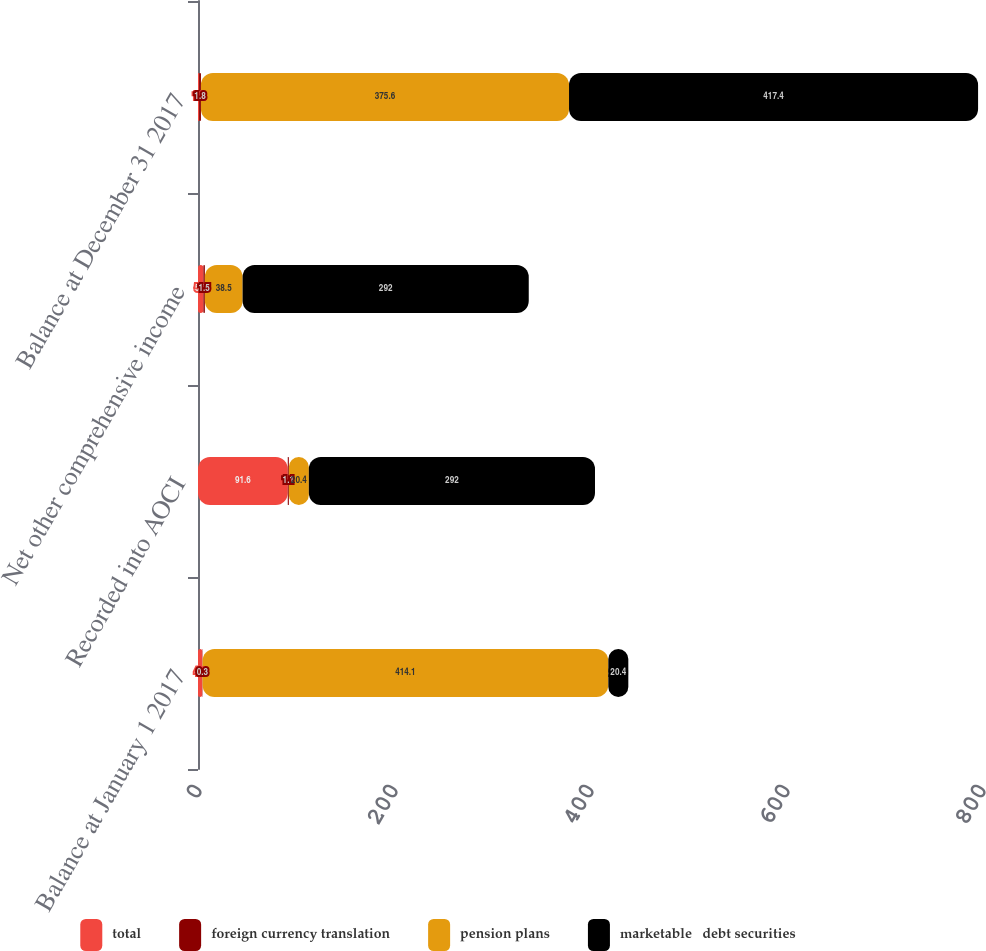Convert chart. <chart><loc_0><loc_0><loc_500><loc_500><stacked_bar_chart><ecel><fcel>Balance at January 1 2017<fcel>Recorded into AOCI<fcel>Net other comprehensive income<fcel>Balance at December 31 2017<nl><fcel>total<fcel>4.3<fcel>91.6<fcel>5.5<fcel>1.2<nl><fcel>foreign currency translation<fcel>0.3<fcel>1.1<fcel>1.5<fcel>1.8<nl><fcel>pension plans<fcel>414.1<fcel>20.4<fcel>38.5<fcel>375.6<nl><fcel>marketable   debt securities<fcel>20.4<fcel>292<fcel>292<fcel>417.4<nl></chart> 